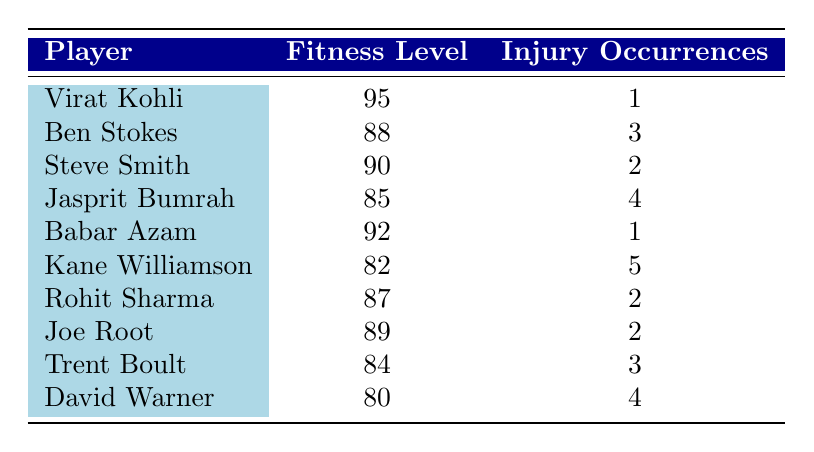What is the fitness level of Virat Kohli? From the table, Virat Kohli is listed in the first row, and his fitness level is indicated as 95.
Answer: 95 How many injury occurrences does Babar Azam have? Babar Azam is found in the fifth row of the table, where it clearly states that he has 1 injury occurrence.
Answer: 1 Who has the highest fitness level, and what is that level? By checking the first column for fitness levels, Virat Kohli has the highest level of 95, as all other fitness levels are lower.
Answer: Virat Kohli, 95 Calculate the average fitness level of all players. The fitness levels are 95, 88, 90, 85, 92, 82, 87, 89, 84, and 80. Adding these gives a total of 898. There are 10 players, so the average fitness level is 898 / 10 = 89.8.
Answer: 89.8 Is it true that Kane Williamson has more injury occurrences than Rohit Sharma? Kane Williamson has 5 injury occurrences, while Rohit Sharma has 2, which means Kane Williamson indeed has more.
Answer: Yes What is the difference in injury occurrences between the player with the highest and lowest fitness levels? The player with the highest fitness level (Virat Kohli) has 1 injury occurrence, and the player with the lowest fitness level (David Warner) has 4 injury occurrences. The difference is 4 - 1 = 3.
Answer: 3 If we look at the average injuries for players with fitness levels above 85, what do we find? The players with fitness levels above 85 are Virat Kohli (1), Ben Stokes (3), Steve Smith (2), Babar Azam (1), Rohit Sharma (2), and Joe Root (2). Their total injuries are 1 + 3 + 2 + 1 + 2 + 2 = 11. There are 6 such players, so the average injuries are 11 / 6 ≈ 1.83.
Answer: 1.83 Which player has the most injuries, and how many does he have? Kane Williamson has the highest number of injury occurrences, which is 5. This is confirmed by checking the injury occurrences column.
Answer: Kane Williamson, 5 Is it correct that all players with fitness levels above 90 have 2 or fewer injury occurrences? The players above 90 are Virat Kohli (1), Babar Azam (1), and Steve Smith (2). All these players have 2 or fewer occurrences, confirming the statement as true.
Answer: Yes 